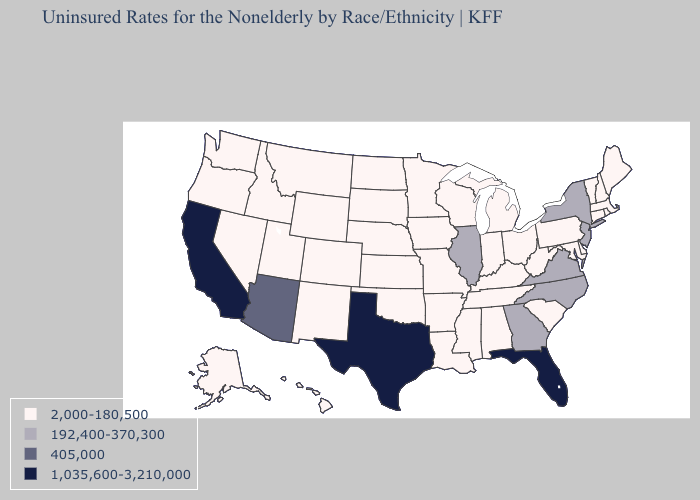Does Virginia have the lowest value in the USA?
Keep it brief. No. What is the lowest value in the South?
Be succinct. 2,000-180,500. What is the value of Washington?
Quick response, please. 2,000-180,500. Which states have the lowest value in the MidWest?
Quick response, please. Indiana, Iowa, Kansas, Michigan, Minnesota, Missouri, Nebraska, North Dakota, Ohio, South Dakota, Wisconsin. Which states have the lowest value in the Northeast?
Short answer required. Connecticut, Maine, Massachusetts, New Hampshire, Pennsylvania, Rhode Island, Vermont. Among the states that border Indiana , which have the lowest value?
Short answer required. Kentucky, Michigan, Ohio. Does Michigan have the highest value in the MidWest?
Concise answer only. No. What is the value of Rhode Island?
Be succinct. 2,000-180,500. Which states hav the highest value in the MidWest?
Write a very short answer. Illinois. Does Arizona have the lowest value in the West?
Concise answer only. No. What is the highest value in the USA?
Answer briefly. 1,035,600-3,210,000. What is the value of Virginia?
Keep it brief. 192,400-370,300. Does Arizona have the lowest value in the West?
Quick response, please. No. How many symbols are there in the legend?
Short answer required. 4. Does the first symbol in the legend represent the smallest category?
Write a very short answer. Yes. 